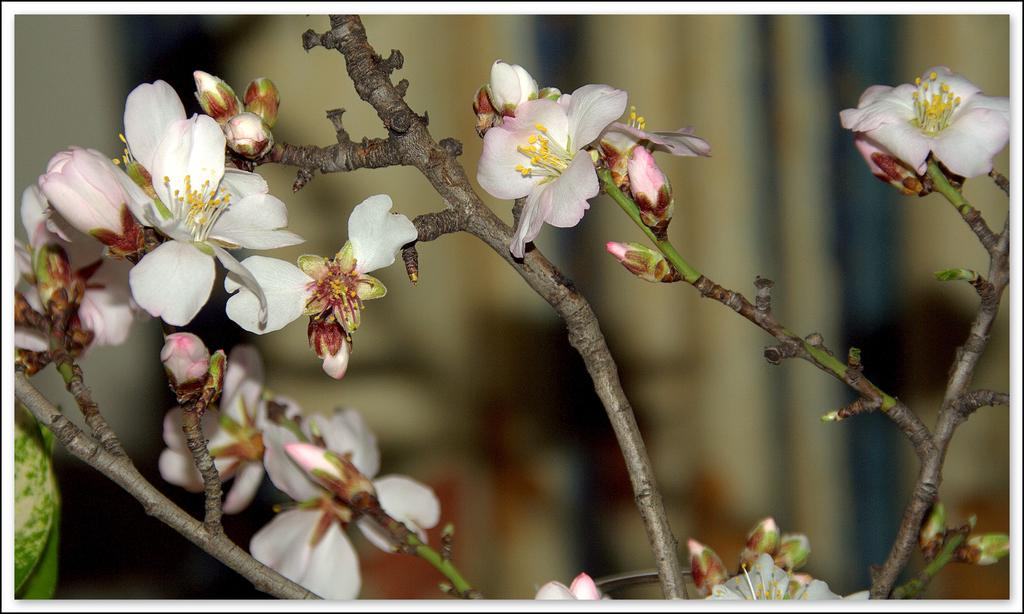What type of flora can be seen in the image? There are flowers and plants in the image. Can you describe the background of the image? The background of the image is blurred. How many ears of corn are visible in the image? There are no ears of corn present in the image. What type of ship can be seen sailing in the background of the image? There is no ship visible in the image; the background is blurred. 